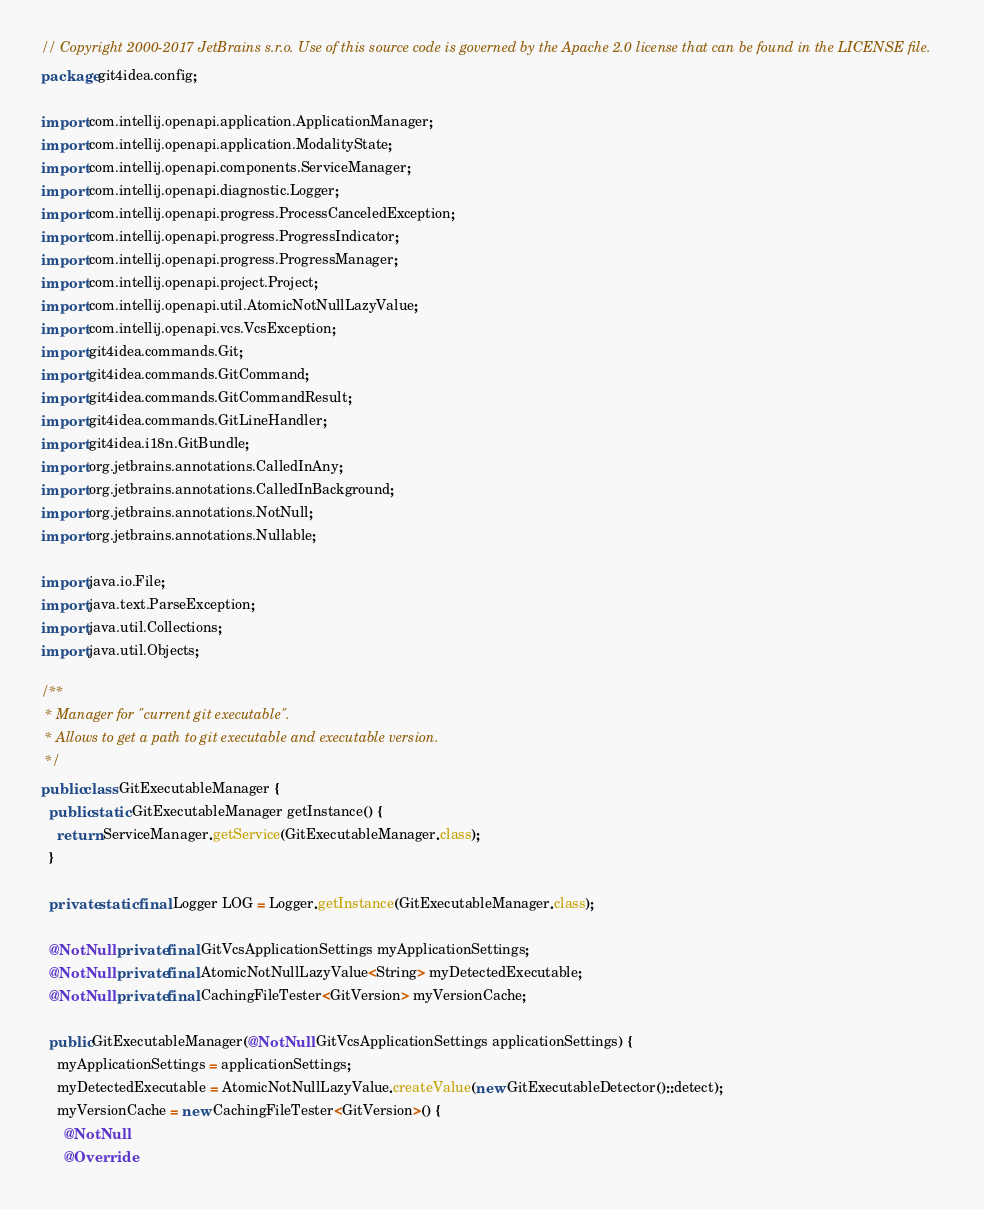<code> <loc_0><loc_0><loc_500><loc_500><_Java_>// Copyright 2000-2017 JetBrains s.r.o. Use of this source code is governed by the Apache 2.0 license that can be found in the LICENSE file.
package git4idea.config;

import com.intellij.openapi.application.ApplicationManager;
import com.intellij.openapi.application.ModalityState;
import com.intellij.openapi.components.ServiceManager;
import com.intellij.openapi.diagnostic.Logger;
import com.intellij.openapi.progress.ProcessCanceledException;
import com.intellij.openapi.progress.ProgressIndicator;
import com.intellij.openapi.progress.ProgressManager;
import com.intellij.openapi.project.Project;
import com.intellij.openapi.util.AtomicNotNullLazyValue;
import com.intellij.openapi.vcs.VcsException;
import git4idea.commands.Git;
import git4idea.commands.GitCommand;
import git4idea.commands.GitCommandResult;
import git4idea.commands.GitLineHandler;
import git4idea.i18n.GitBundle;
import org.jetbrains.annotations.CalledInAny;
import org.jetbrains.annotations.CalledInBackground;
import org.jetbrains.annotations.NotNull;
import org.jetbrains.annotations.Nullable;

import java.io.File;
import java.text.ParseException;
import java.util.Collections;
import java.util.Objects;

/**
 * Manager for "current git executable".
 * Allows to get a path to git executable and executable version.
 */
public class GitExecutableManager {
  public static GitExecutableManager getInstance() {
    return ServiceManager.getService(GitExecutableManager.class);
  }

  private static final Logger LOG = Logger.getInstance(GitExecutableManager.class);

  @NotNull private final GitVcsApplicationSettings myApplicationSettings;
  @NotNull private final AtomicNotNullLazyValue<String> myDetectedExecutable;
  @NotNull private final CachingFileTester<GitVersion> myVersionCache;

  public GitExecutableManager(@NotNull GitVcsApplicationSettings applicationSettings) {
    myApplicationSettings = applicationSettings;
    myDetectedExecutable = AtomicNotNullLazyValue.createValue(new GitExecutableDetector()::detect);
    myVersionCache = new CachingFileTester<GitVersion>() {
      @NotNull
      @Override</code> 